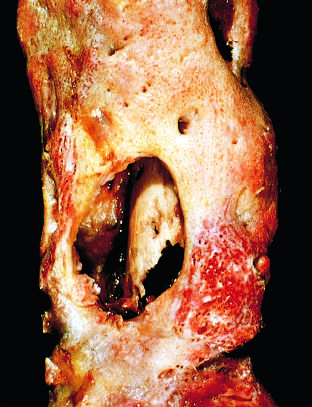what does the drainage tract in the subperiosteal shell of viable new bone show?
Answer the question using a single word or phrase. Inner native necrotic cortex 